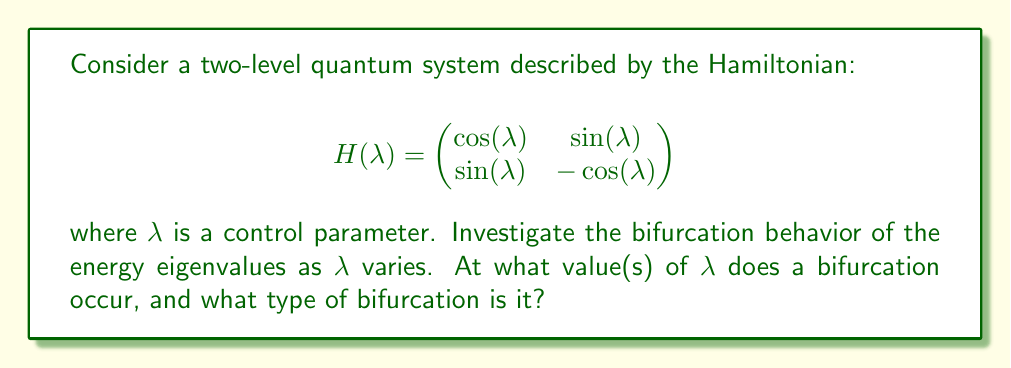Help me with this question. 1) First, we need to find the eigenvalues of the Hamiltonian. The characteristic equation is:

   $$\det(H - EI) = \begin{vmatrix}
   \cos(\lambda) - E & \sin(\lambda) \\
   \sin(\lambda) & -\cos(\lambda) - E
   \end{vmatrix} = 0$$

2) Expanding this determinant:

   $$(\cos(\lambda) - E)(-\cos(\lambda) - E) - \sin^2(\lambda) = 0$$
   $$E^2 - \cos^2(\lambda) - \sin^2(\lambda) = 0$$
   $$E^2 = 1$$ (using the identity $\cos^2(\lambda) + \sin^2(\lambda) = 1$)

3) Solving for E:

   $$E = \pm 1$$

4) This shows that the eigenvalues are constant (±1) regardless of $\lambda$. There is no bifurcation in the eigenvalues.

5) However, we can investigate the eigenvectors. For $E = 1$, the eigenvector equation is:

   $$\begin{pmatrix}
   \cos(\lambda) - 1 & \sin(\lambda) \\
   \sin(\lambda) & -\cos(\lambda) - 1
   \end{pmatrix} \begin{pmatrix} x \\ y \end{pmatrix} = \begin{pmatrix} 0 \\ 0 \end{pmatrix}$$

6) This gives us:
   
   $$x = \frac{\sin(\lambda)}{\cos(\lambda) - 1} y$$

7) The eigenvector changes direction continuously as $\lambda$ varies, except when $\cos(\lambda) = 1$, which occurs at $\lambda = 0, 2\pi, 4\pi, ...$

8) At these points, the eigenvector switches abruptly between $\begin{pmatrix} 1 \\ 0 \end{pmatrix}$ and $\begin{pmatrix} 0 \\ 1 \end{pmatrix}$.

9) This behavior is characteristic of a transcritical bifurcation in the eigenvector space, occurring at $\lambda = 0, 2\pi, 4\pi, ...$
Answer: Transcritical bifurcation in eigenvector space at $\lambda = 0, 2\pi, 4\pi, ...$ 